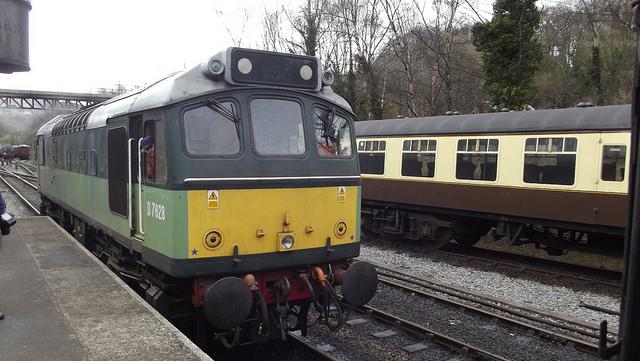Are the trains freight trains?
Keep it brief. No. What number is displayed on the train to the left?
Quick response, please. 07628. Are the trains the same color?
Concise answer only. No. What is bordering the train tracks?
Be succinct. Platform. What time of day is it?
Keep it brief. Morning. 